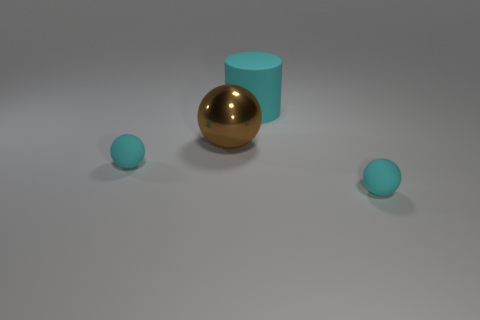Add 2 cyan rubber objects. How many objects exist? 6 Subtract all balls. How many objects are left? 1 Add 2 big brown metallic things. How many big brown metallic things exist? 3 Subtract 1 brown balls. How many objects are left? 3 Subtract all shiny balls. Subtract all tiny gray rubber balls. How many objects are left? 3 Add 2 cyan things. How many cyan things are left? 5 